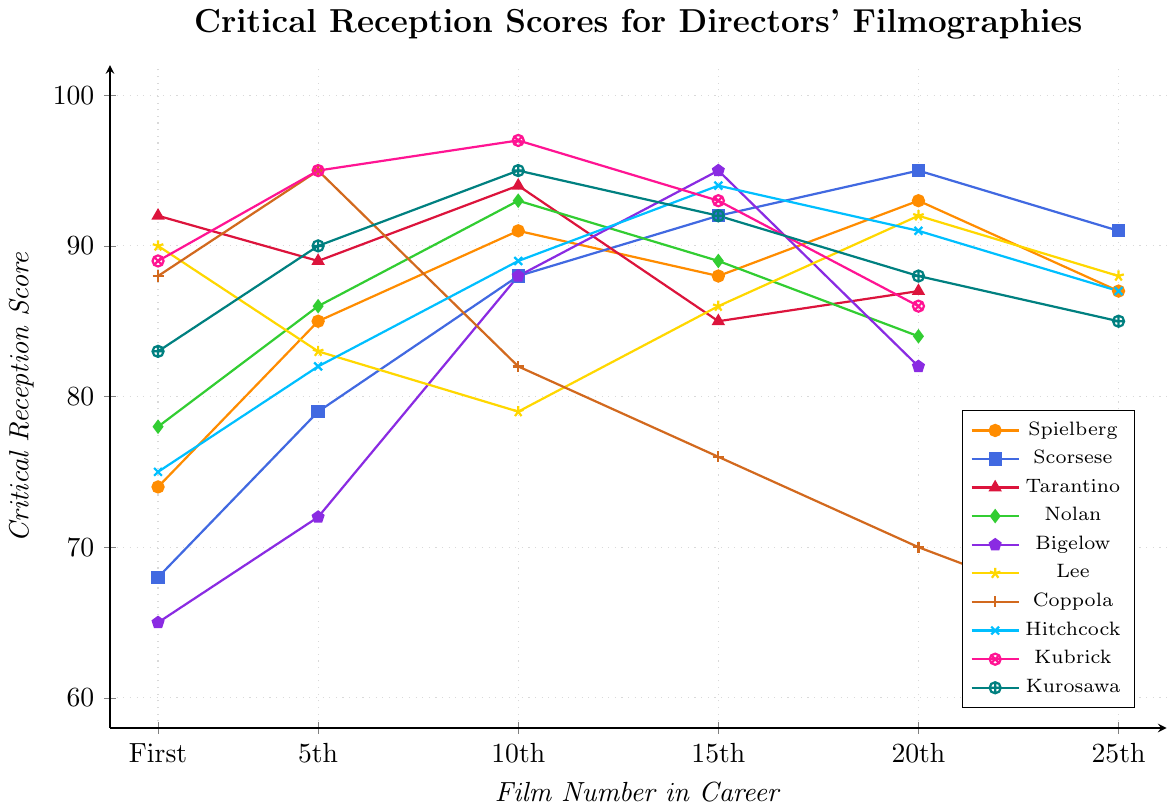What is the highest and lowest critical reception score for Francis Ford Coppola? The highest score is found by locating the peak point on his line, which is 95 for the 5th film. The lowest score is the trough, which is 65 for the 25th film.
Answer: Highest: 95, Lowest: 65 Who has the highest critical reception score on their first film? Look for the director with the highest starting point on the chart, which is represented by the first dot for each line. Quentin Tarantino’s first film has a score of 92.
Answer: Quentin Tarantino Compare the critical reception scores of Kathryn Bigelow and Alfred Hitchcock on their 15th films. Who has the higher score? Locate the 15th film on the x-axis for both directors; Kathryn Bigelow's score is 95, Alfred Hitchcock's score is 94.
Answer: Kathryn Bigelow What is the average score of Steven Spielberg's first, 10th, and 20th films? Add the scores of the first (74), 10th (91), and 20th (93) films and divide by 3: (74 + 91 + 93) / 3 = 86.
Answer: 86 Which director has the most significant decrease in critical reception score from their 5th to 10th film? Calculate the difference between the scores of the 5th and 10th films for each director. Francis Ford Coppola drops from 95 to 82, a decrease of 13 points, which is the largest.
Answer: Francis Ford Coppola How many directors have a critical reception score of 95 at any point in their career? Count the directors with a data point at 95. Martin Scorsese (20th film), Kathryn Bigelow (15th film), Francis Ford Coppola (5th film), Stanley Kubrick (5th film, 10th film), and Akira Kurosawa (10th film) have 95 as a score.
Answer: 5 directors Whose critical reception score shows a steady increase from the 1st to the 20th film? Each director is examined for a consistent upward trend from the 1st to the 20th films. Martin Scorsese’s scores improve from 68 to 95.
Answer: Martin Scorsese Which directors have a critical reception score of 88 for their 10th film? Identify the directors whose score is 88 at the 10th film marker. Steven Spielberg and Kathryn Bigelow both have an 88 score for their 10th film.
Answer: Steven Spielberg, Kathryn Bigelow 